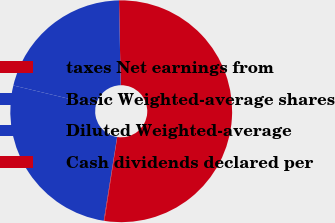<chart> <loc_0><loc_0><loc_500><loc_500><pie_chart><fcel>taxes Net earnings from<fcel>Basic Weighted-average shares<fcel>Diluted Weighted-average<fcel>Cash dividends declared per<nl><fcel>52.74%<fcel>20.95%<fcel>26.22%<fcel>0.09%<nl></chart> 